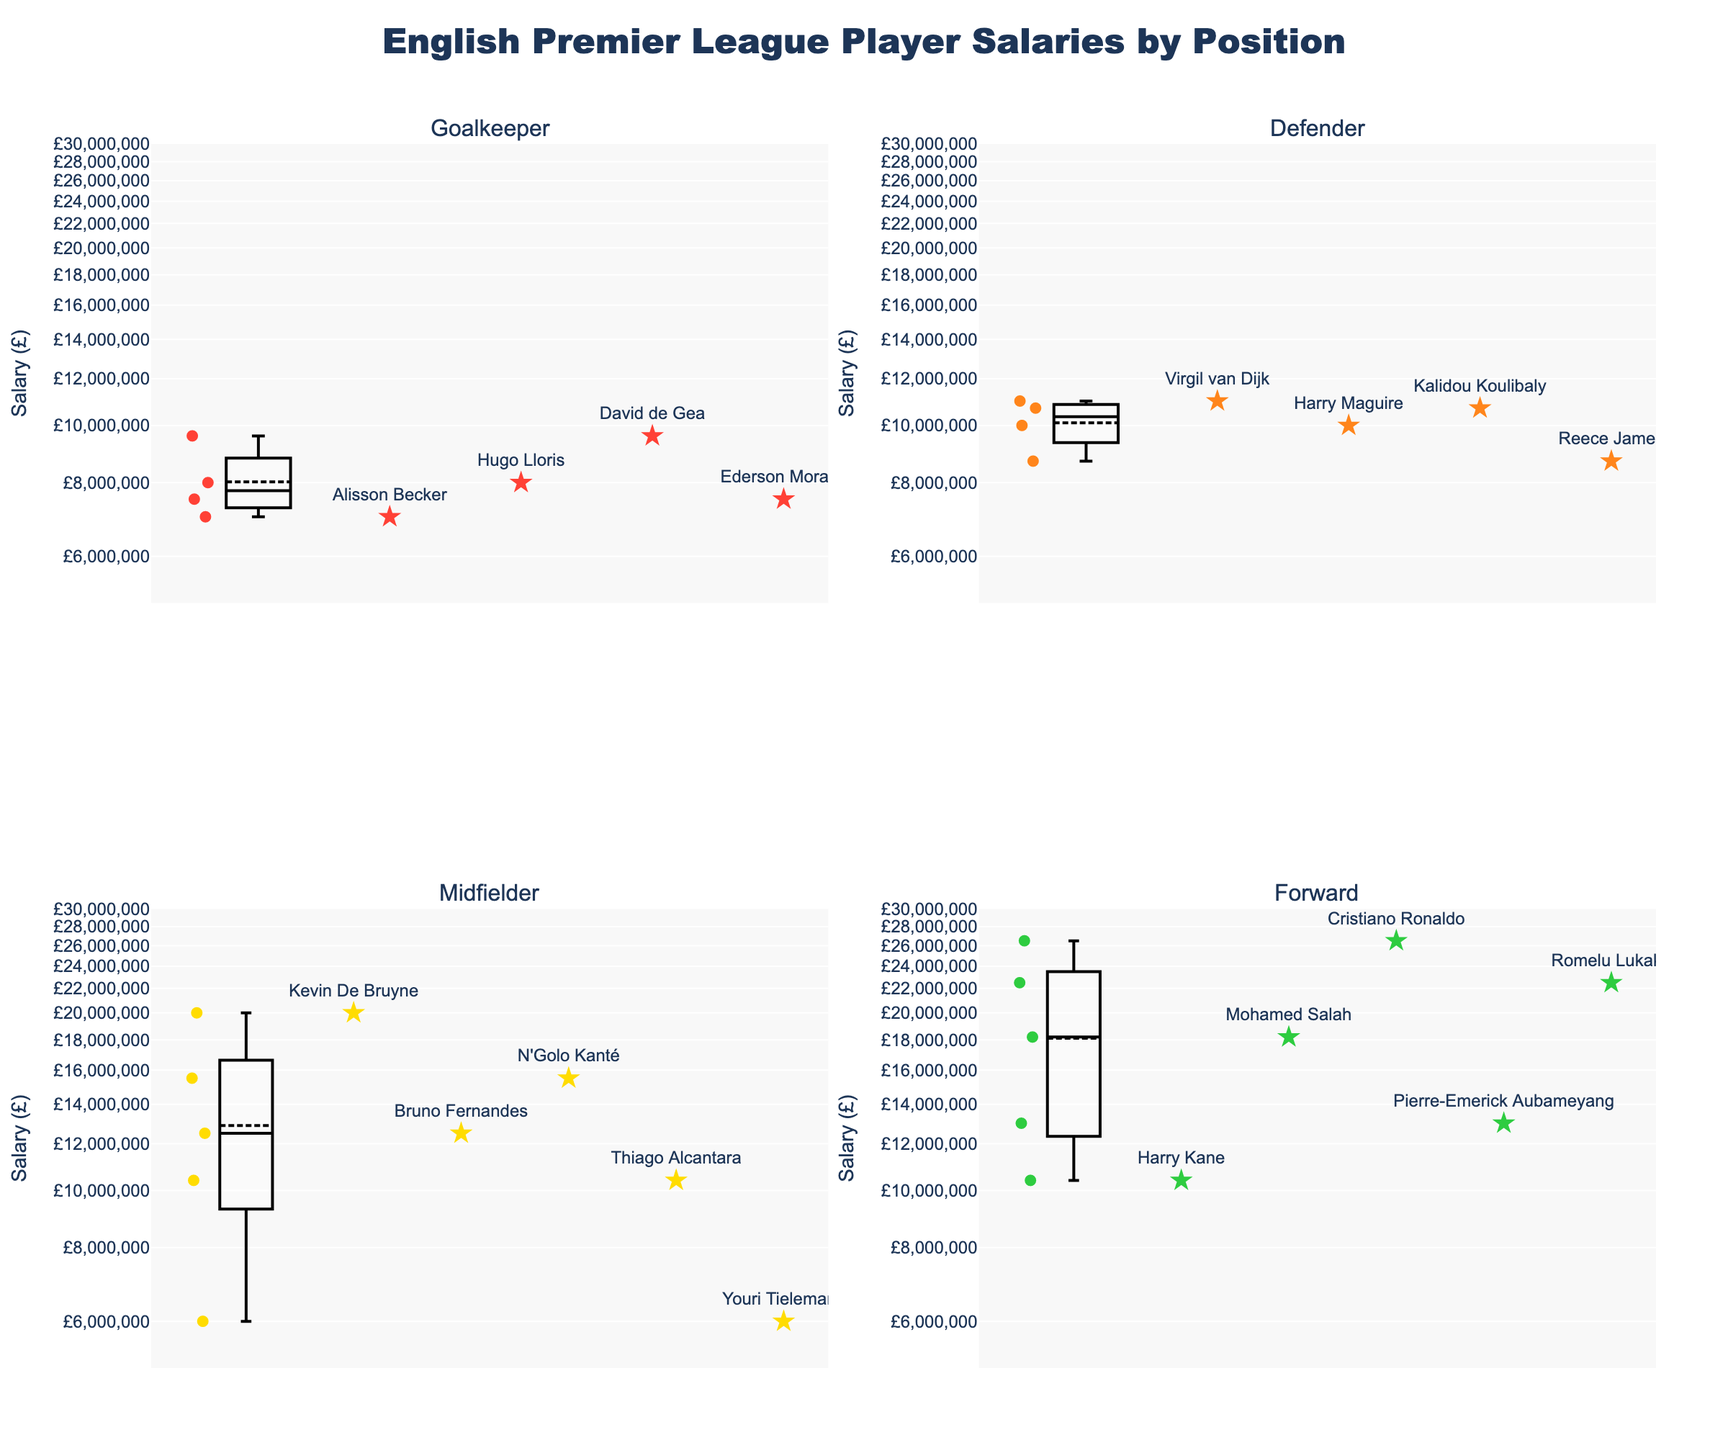Which position has the highest salary? From the figure, notice that the highest salary is marked by Cristiano Ronaldo, whose position is Forward.
Answer: Forward What is the general trend for the salaries of Goalkeepers compared to Forwards? By observing the subplot for Goalkeepers and Forwards, it is clear that Forwards generally have higher salaries, as the data points and box plot for Forwards are higher on the log scale axis compared to Goalkeepers.
Answer: Forwards have generally higher salaries Which position has the largest salary range? Compare the length of the box plot whiskers in all subplots. The Forward position has the widest range, starting from around £10,400,000 to £26,500,000.
Answer: Forward How does the median salary of Midfielders compare to that of Defenders? The median salary line in the Midfielders' box plot is higher than that of Defenders. Specifically, the median for Midfielders is around £10,400,000, while for Defenders it is around £10,000,000.
Answer: Midfielders have a higher median salary compared to Defenders Which player has the lowest salary among Midfielders? From the subplot for Midfielders, Youri Tielemans is shown with the lowest salary at £6,000,000.
Answer: Youri Tielemans What is the difference between the highest and lowest salaries for Goalkeepers? The highest salary for Goalkeepers is £9,600,000 (David de Gea). The lowest salary is £7,000,000 (Alisson Becker). The difference is £9,600,000 - £7,000,000 = £2,600,000.
Answer: £2,600,000 Are there any players with similar salaries in different positions? Observe the data points in the subplots. Kevin De Bruyne (Midfielder) and Romelu Lukaku (Forward) have salaries of £20,000,000 and £22,500,000 respectively, which are relatively close.
Answer: Kevin De Bruyne and Romelu Lukaku have similar salaries What is the average salary of Defenders? Sum the salaries of Defenders (£11,000,000 + £10,000,000 + £10,700,000 + £8,700,000) and divide by 4. Average = (11,000,000 + 10,000,000 + 10,700,000 + 8,700,000) / 4 = 10,100,000.
Answer: £10,100,000 Which position has the least variation in salaries? By comparing the whisker lengths of the box plots, the Goalkeeper position shows the least variation, as the box and whiskers are relatively shorter than those of other positions.
Answer: Goalkeeper 